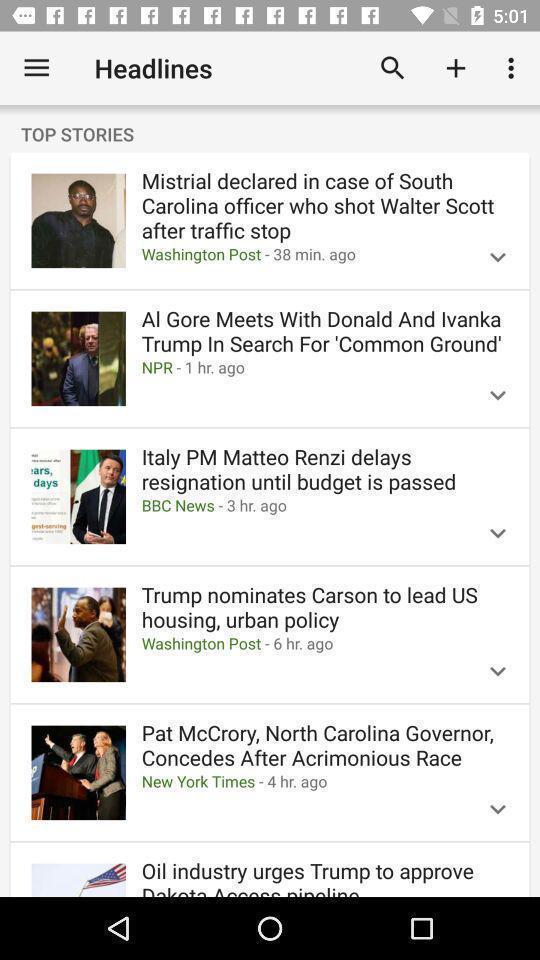Describe the content in this image. Top stories news showing in this page. 